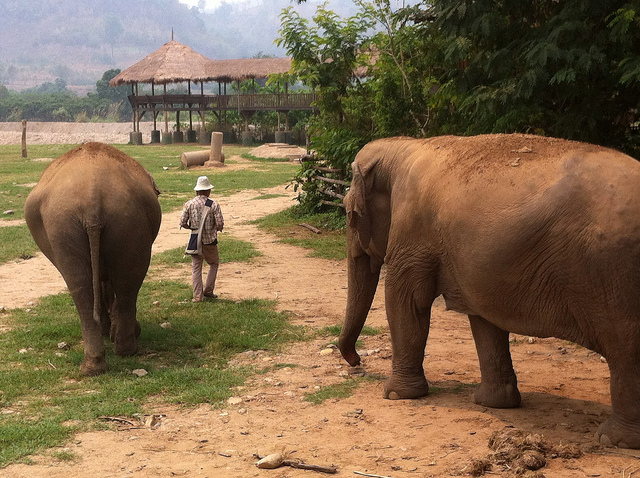How many elephants are following after the man wearing a white hat?
A. three
B. four
C. two
D. five
Answer with the option's letter from the given choices directly. C What is between the elephants?
A. buzzard
B. box
C. bench
D. man D 